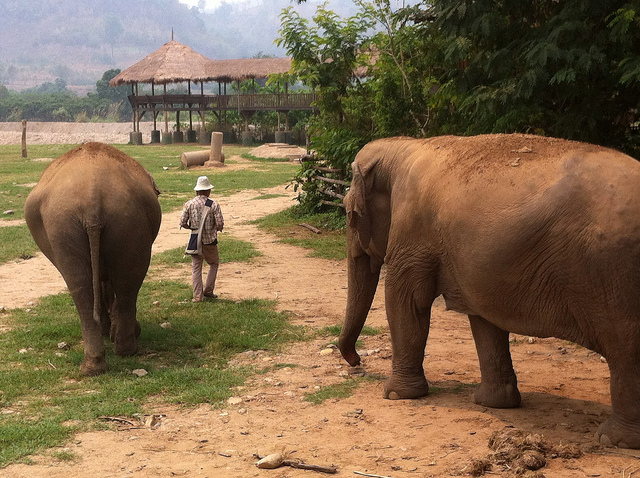How many elephants are following after the man wearing a white hat?
A. three
B. four
C. two
D. five
Answer with the option's letter from the given choices directly. C What is between the elephants?
A. buzzard
B. box
C. bench
D. man D 